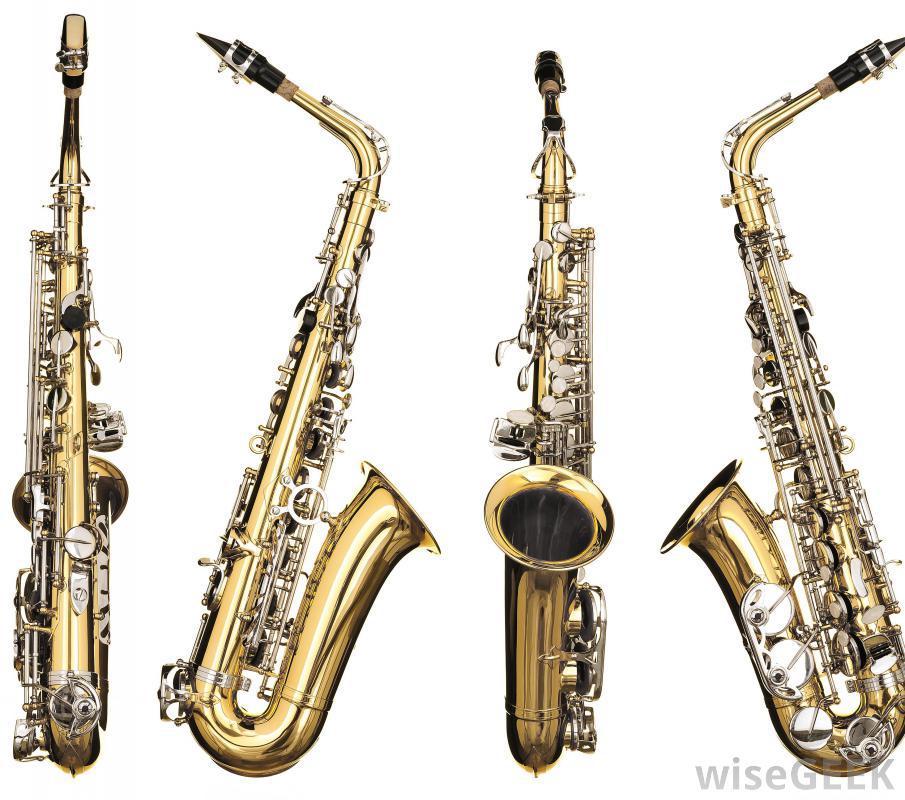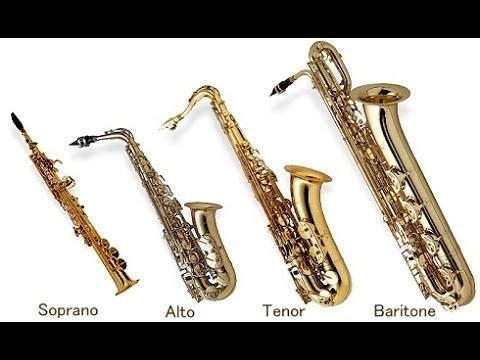The first image is the image on the left, the second image is the image on the right. Assess this claim about the two images: "Each image shows just one saxophone that is out of its case.". Correct or not? Answer yes or no. No. 